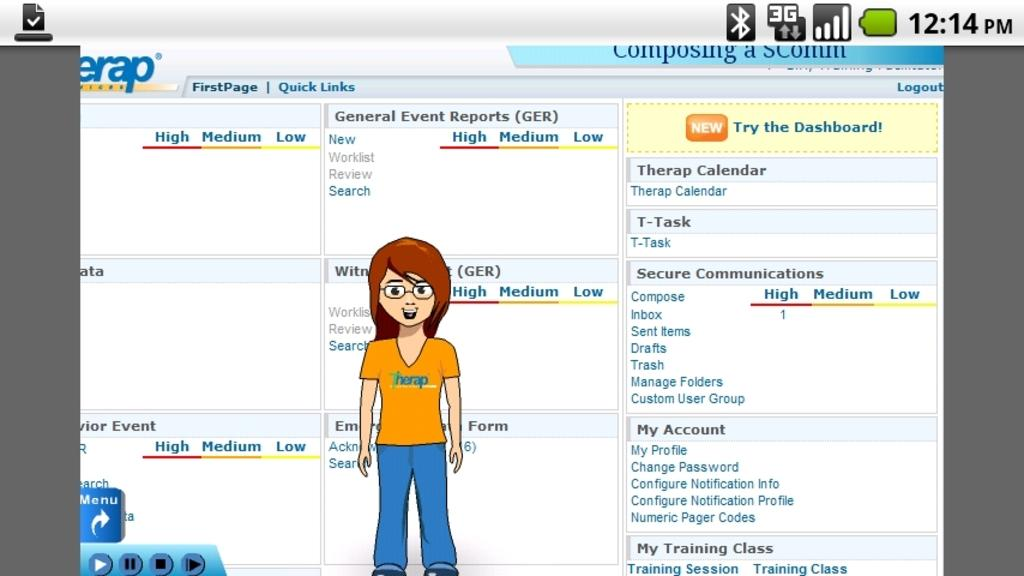What type of image is shown in the screenshot? The image is a screenshot. Can you describe the main subject in the screenshot? There is a lady standing in the center of the screenshot. What is the rate of the lady's heartbeat in the screenshot? The screenshot does not provide information about the lady's heartbeat rate. 